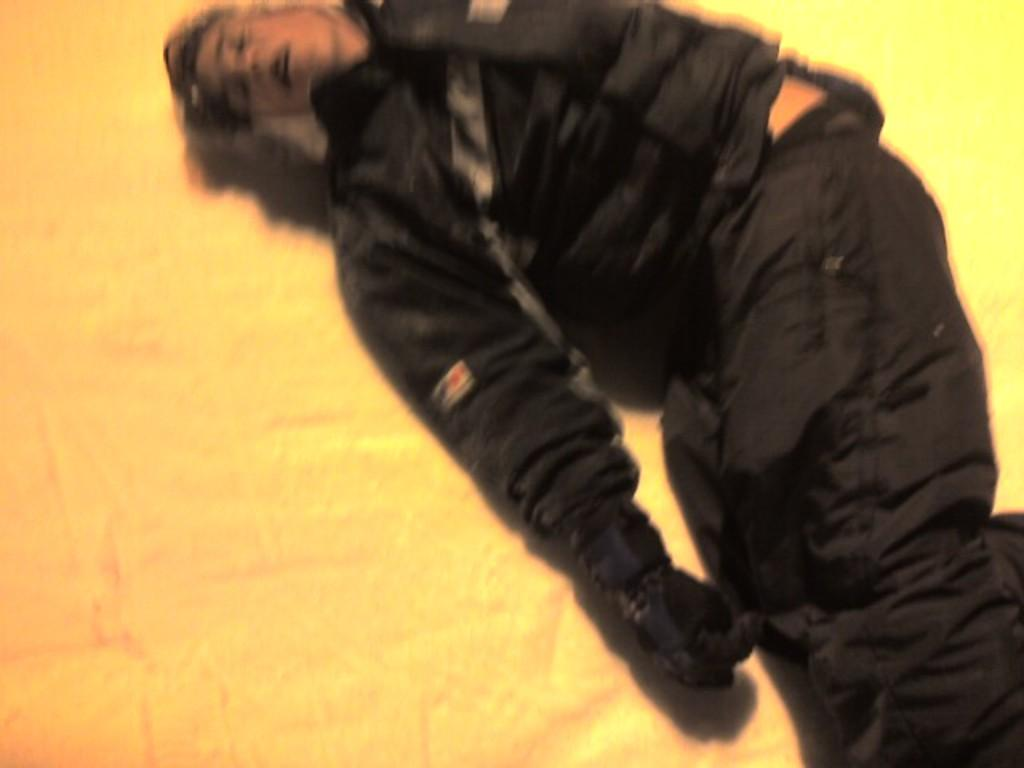What is the person in the image doing? The person is lying in the image. What color is the coat the person is wearing? The person is wearing a black coat. What type of pants is the person wearing? The person is wearing black trousers. What type of songs can be heard playing in the background of the image? There is no indication of any songs or background music in the image. 